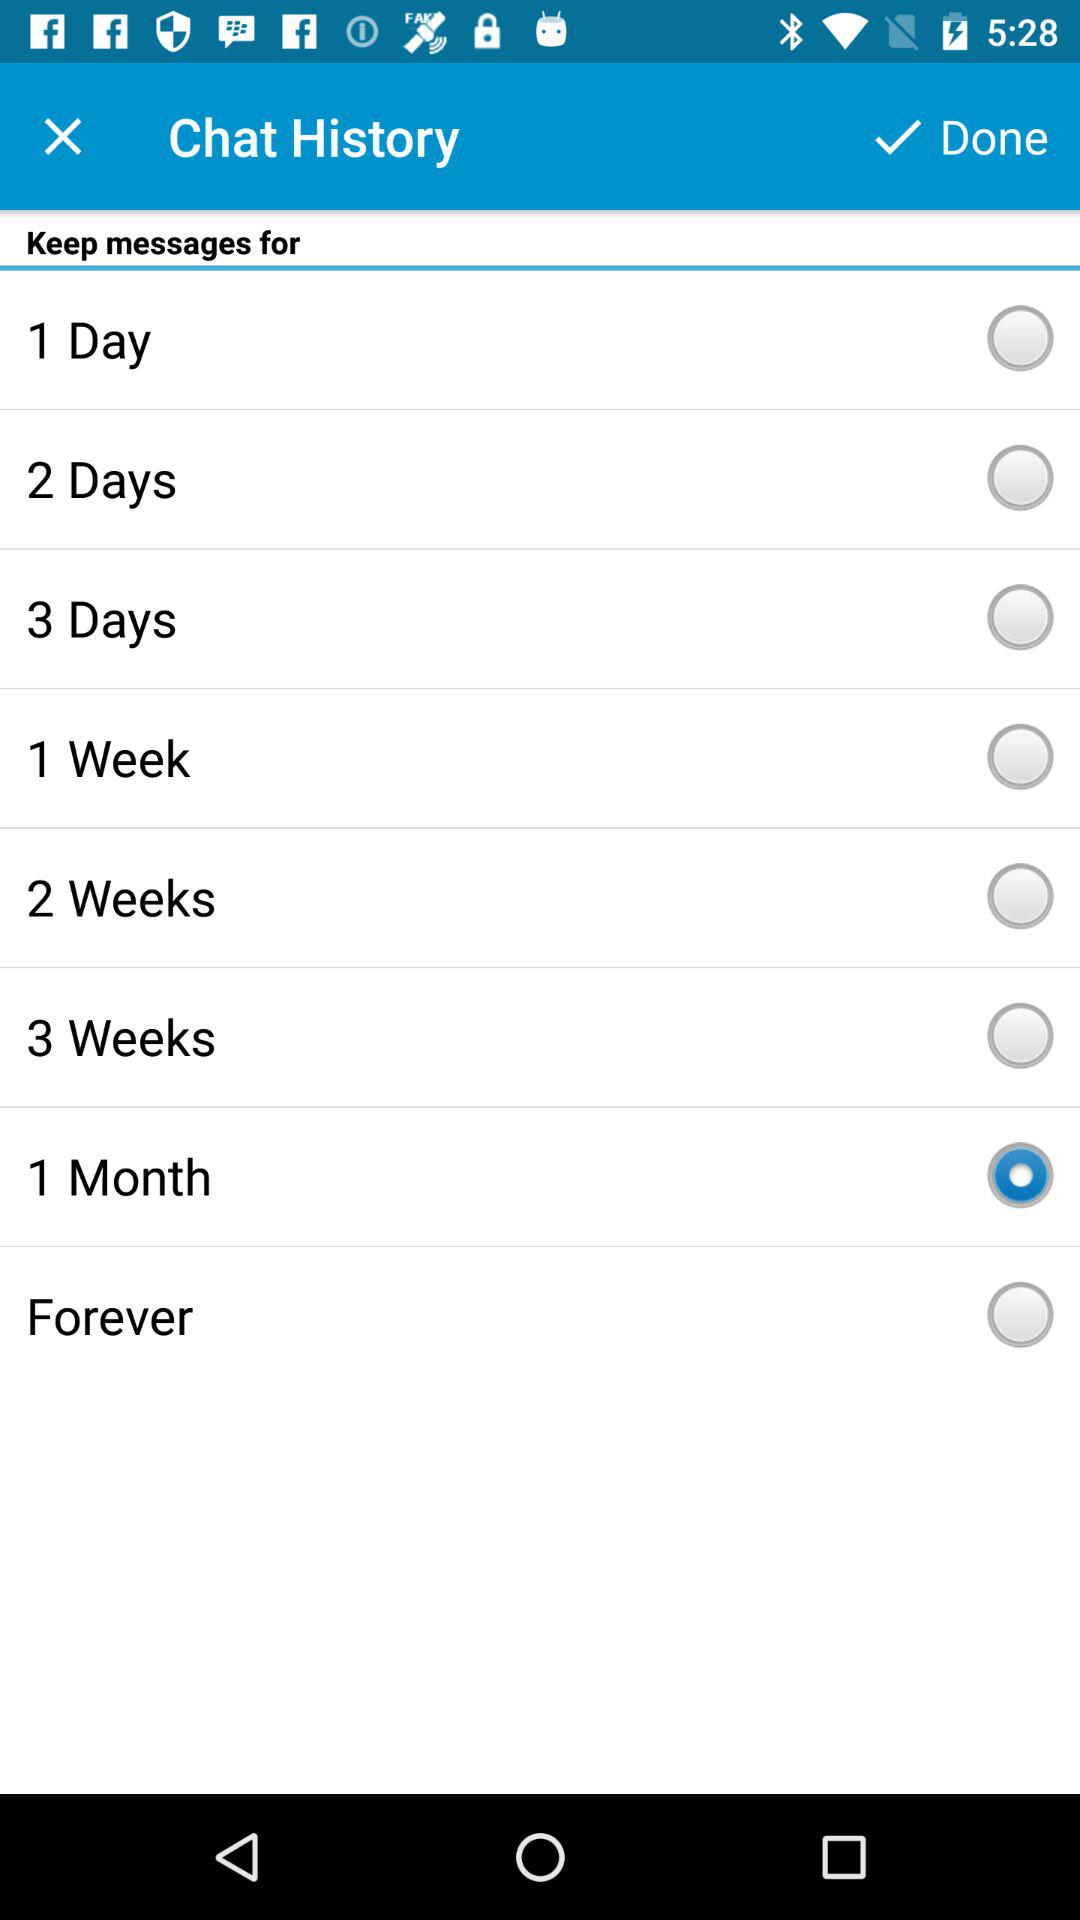What is the name of the user?
When the provided information is insufficient, respond with <no answer>. <no answer> 